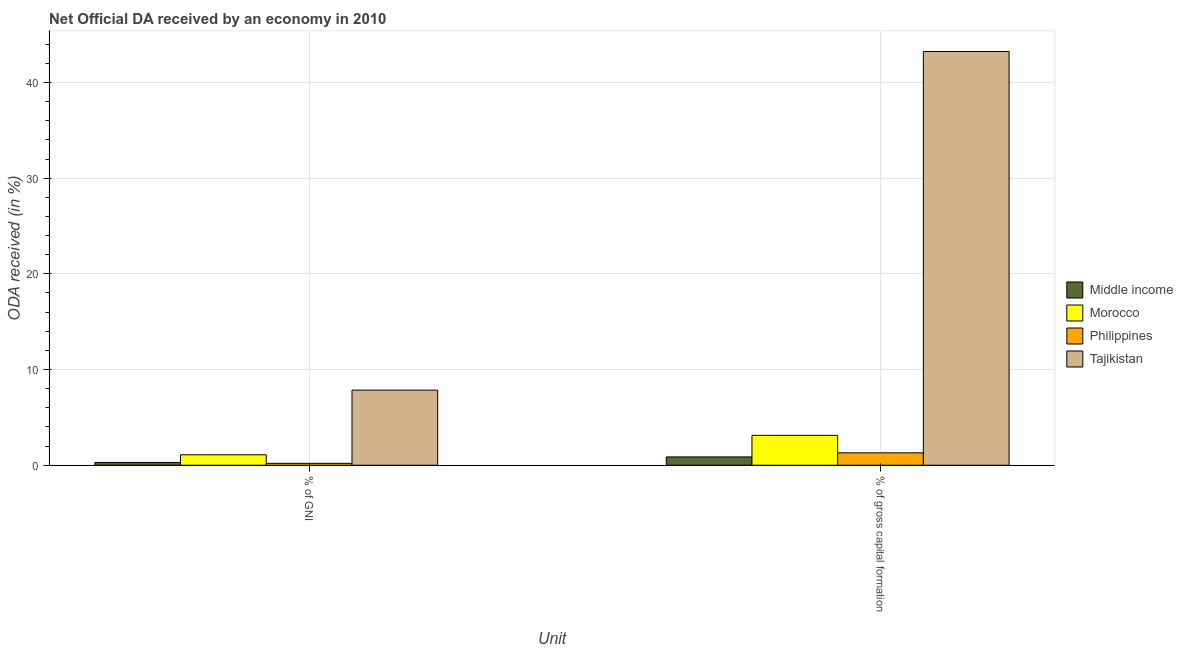How many different coloured bars are there?
Provide a short and direct response. 4. How many groups of bars are there?
Your response must be concise. 2. Are the number of bars on each tick of the X-axis equal?
Your answer should be compact. Yes. How many bars are there on the 2nd tick from the right?
Make the answer very short. 4. What is the label of the 2nd group of bars from the left?
Your answer should be compact. % of gross capital formation. What is the oda received as percentage of gni in Middle income?
Make the answer very short. 0.29. Across all countries, what is the maximum oda received as percentage of gni?
Keep it short and to the point. 7.85. Across all countries, what is the minimum oda received as percentage of gni?
Give a very brief answer. 0.2. In which country was the oda received as percentage of gni maximum?
Ensure brevity in your answer.  Tajikistan. In which country was the oda received as percentage of gni minimum?
Give a very brief answer. Philippines. What is the total oda received as percentage of gni in the graph?
Your answer should be compact. 9.43. What is the difference between the oda received as percentage of gross capital formation in Middle income and that in Morocco?
Make the answer very short. -2.25. What is the difference between the oda received as percentage of gross capital formation in Tajikistan and the oda received as percentage of gni in Philippines?
Your response must be concise. 43.03. What is the average oda received as percentage of gni per country?
Ensure brevity in your answer.  2.36. What is the difference between the oda received as percentage of gni and oda received as percentage of gross capital formation in Tajikistan?
Provide a short and direct response. -35.39. What is the ratio of the oda received as percentage of gross capital formation in Philippines to that in Middle income?
Your answer should be very brief. 1.49. Is the oda received as percentage of gross capital formation in Tajikistan less than that in Morocco?
Provide a short and direct response. No. In how many countries, is the oda received as percentage of gross capital formation greater than the average oda received as percentage of gross capital formation taken over all countries?
Provide a succinct answer. 1. What does the 1st bar from the left in % of GNI represents?
Your answer should be very brief. Middle income. What does the 3rd bar from the right in % of gross capital formation represents?
Keep it short and to the point. Morocco. How many countries are there in the graph?
Ensure brevity in your answer.  4. What is the difference between two consecutive major ticks on the Y-axis?
Provide a short and direct response. 10. Are the values on the major ticks of Y-axis written in scientific E-notation?
Provide a succinct answer. No. Does the graph contain grids?
Your answer should be very brief. Yes. Where does the legend appear in the graph?
Keep it short and to the point. Center right. How are the legend labels stacked?
Provide a short and direct response. Vertical. What is the title of the graph?
Provide a succinct answer. Net Official DA received by an economy in 2010. What is the label or title of the X-axis?
Keep it short and to the point. Unit. What is the label or title of the Y-axis?
Provide a short and direct response. ODA received (in %). What is the ODA received (in %) of Middle income in % of GNI?
Offer a terse response. 0.29. What is the ODA received (in %) of Morocco in % of GNI?
Your answer should be compact. 1.09. What is the ODA received (in %) in Philippines in % of GNI?
Make the answer very short. 0.2. What is the ODA received (in %) of Tajikistan in % of GNI?
Offer a terse response. 7.85. What is the ODA received (in %) in Middle income in % of gross capital formation?
Make the answer very short. 0.87. What is the ODA received (in %) of Morocco in % of gross capital formation?
Provide a short and direct response. 3.12. What is the ODA received (in %) of Philippines in % of gross capital formation?
Provide a succinct answer. 1.3. What is the ODA received (in %) of Tajikistan in % of gross capital formation?
Your answer should be very brief. 43.23. Across all Unit, what is the maximum ODA received (in %) in Middle income?
Provide a short and direct response. 0.87. Across all Unit, what is the maximum ODA received (in %) of Morocco?
Provide a short and direct response. 3.12. Across all Unit, what is the maximum ODA received (in %) in Philippines?
Make the answer very short. 1.3. Across all Unit, what is the maximum ODA received (in %) of Tajikistan?
Offer a very short reply. 43.23. Across all Unit, what is the minimum ODA received (in %) of Middle income?
Give a very brief answer. 0.29. Across all Unit, what is the minimum ODA received (in %) of Morocco?
Provide a short and direct response. 1.09. Across all Unit, what is the minimum ODA received (in %) of Philippines?
Offer a very short reply. 0.2. Across all Unit, what is the minimum ODA received (in %) in Tajikistan?
Provide a short and direct response. 7.85. What is the total ODA received (in %) of Middle income in the graph?
Offer a very short reply. 1.16. What is the total ODA received (in %) of Morocco in the graph?
Make the answer very short. 4.22. What is the total ODA received (in %) in Philippines in the graph?
Make the answer very short. 1.5. What is the total ODA received (in %) of Tajikistan in the graph?
Your answer should be very brief. 51.08. What is the difference between the ODA received (in %) in Middle income in % of GNI and that in % of gross capital formation?
Your answer should be compact. -0.58. What is the difference between the ODA received (in %) in Morocco in % of GNI and that in % of gross capital formation?
Offer a very short reply. -2.03. What is the difference between the ODA received (in %) in Philippines in % of GNI and that in % of gross capital formation?
Offer a very short reply. -1.1. What is the difference between the ODA received (in %) in Tajikistan in % of GNI and that in % of gross capital formation?
Make the answer very short. -35.39. What is the difference between the ODA received (in %) in Middle income in % of GNI and the ODA received (in %) in Morocco in % of gross capital formation?
Provide a succinct answer. -2.83. What is the difference between the ODA received (in %) of Middle income in % of GNI and the ODA received (in %) of Philippines in % of gross capital formation?
Offer a terse response. -1. What is the difference between the ODA received (in %) of Middle income in % of GNI and the ODA received (in %) of Tajikistan in % of gross capital formation?
Give a very brief answer. -42.94. What is the difference between the ODA received (in %) in Morocco in % of GNI and the ODA received (in %) in Philippines in % of gross capital formation?
Your response must be concise. -0.2. What is the difference between the ODA received (in %) in Morocco in % of GNI and the ODA received (in %) in Tajikistan in % of gross capital formation?
Provide a short and direct response. -42.14. What is the difference between the ODA received (in %) of Philippines in % of GNI and the ODA received (in %) of Tajikistan in % of gross capital formation?
Keep it short and to the point. -43.03. What is the average ODA received (in %) in Middle income per Unit?
Your response must be concise. 0.58. What is the average ODA received (in %) of Morocco per Unit?
Make the answer very short. 2.11. What is the average ODA received (in %) of Philippines per Unit?
Provide a short and direct response. 0.75. What is the average ODA received (in %) in Tajikistan per Unit?
Provide a short and direct response. 25.54. What is the difference between the ODA received (in %) in Middle income and ODA received (in %) in Morocco in % of GNI?
Provide a short and direct response. -0.8. What is the difference between the ODA received (in %) in Middle income and ODA received (in %) in Philippines in % of GNI?
Give a very brief answer. 0.09. What is the difference between the ODA received (in %) in Middle income and ODA received (in %) in Tajikistan in % of GNI?
Offer a very short reply. -7.56. What is the difference between the ODA received (in %) in Morocco and ODA received (in %) in Philippines in % of GNI?
Offer a very short reply. 0.89. What is the difference between the ODA received (in %) in Morocco and ODA received (in %) in Tajikistan in % of GNI?
Your answer should be compact. -6.75. What is the difference between the ODA received (in %) in Philippines and ODA received (in %) in Tajikistan in % of GNI?
Your answer should be compact. -7.65. What is the difference between the ODA received (in %) in Middle income and ODA received (in %) in Morocco in % of gross capital formation?
Make the answer very short. -2.25. What is the difference between the ODA received (in %) in Middle income and ODA received (in %) in Philippines in % of gross capital formation?
Your response must be concise. -0.43. What is the difference between the ODA received (in %) in Middle income and ODA received (in %) in Tajikistan in % of gross capital formation?
Your response must be concise. -42.36. What is the difference between the ODA received (in %) of Morocco and ODA received (in %) of Philippines in % of gross capital formation?
Keep it short and to the point. 1.83. What is the difference between the ODA received (in %) of Morocco and ODA received (in %) of Tajikistan in % of gross capital formation?
Offer a terse response. -40.11. What is the difference between the ODA received (in %) of Philippines and ODA received (in %) of Tajikistan in % of gross capital formation?
Ensure brevity in your answer.  -41.94. What is the ratio of the ODA received (in %) in Middle income in % of GNI to that in % of gross capital formation?
Your answer should be compact. 0.34. What is the ratio of the ODA received (in %) in Morocco in % of GNI to that in % of gross capital formation?
Your response must be concise. 0.35. What is the ratio of the ODA received (in %) in Philippines in % of GNI to that in % of gross capital formation?
Your answer should be compact. 0.15. What is the ratio of the ODA received (in %) in Tajikistan in % of GNI to that in % of gross capital formation?
Provide a short and direct response. 0.18. What is the difference between the highest and the second highest ODA received (in %) of Middle income?
Your answer should be compact. 0.58. What is the difference between the highest and the second highest ODA received (in %) of Morocco?
Provide a succinct answer. 2.03. What is the difference between the highest and the second highest ODA received (in %) of Philippines?
Offer a terse response. 1.1. What is the difference between the highest and the second highest ODA received (in %) in Tajikistan?
Offer a very short reply. 35.39. What is the difference between the highest and the lowest ODA received (in %) of Middle income?
Ensure brevity in your answer.  0.58. What is the difference between the highest and the lowest ODA received (in %) in Morocco?
Offer a terse response. 2.03. What is the difference between the highest and the lowest ODA received (in %) in Philippines?
Offer a terse response. 1.1. What is the difference between the highest and the lowest ODA received (in %) in Tajikistan?
Offer a very short reply. 35.39. 